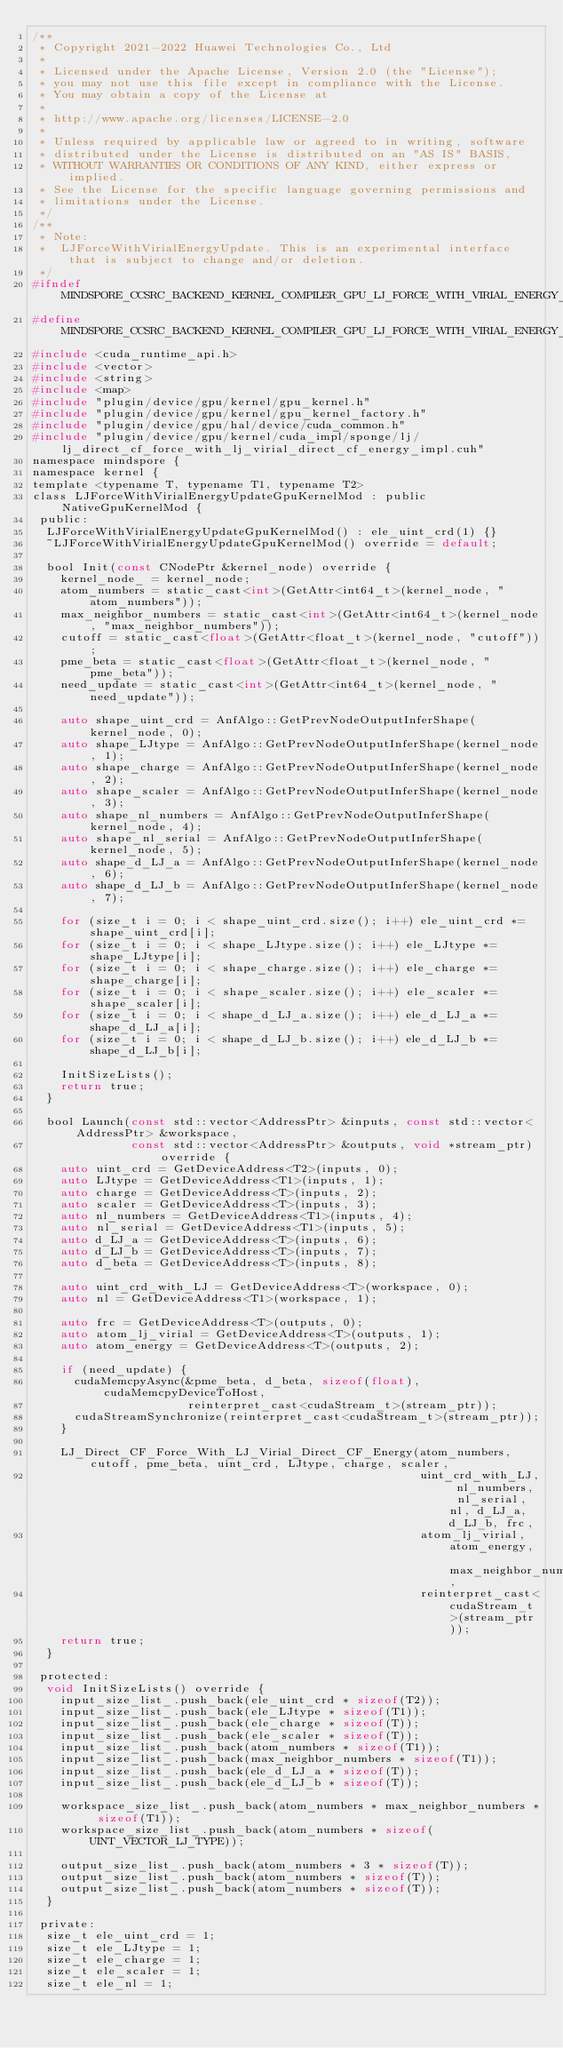Convert code to text. <code><loc_0><loc_0><loc_500><loc_500><_C_>/**
 * Copyright 2021-2022 Huawei Technologies Co., Ltd
 *
 * Licensed under the Apache License, Version 2.0 (the "License");
 * you may not use this file except in compliance with the License.
 * You may obtain a copy of the License at
 *
 * http://www.apache.org/licenses/LICENSE-2.0
 *
 * Unless required by applicable law or agreed to in writing, software
 * distributed under the License is distributed on an "AS IS" BASIS,
 * WITHOUT WARRANTIES OR CONDITIONS OF ANY KIND, either express or implied.
 * See the License for the specific language governing permissions and
 * limitations under the License.
 */
/**
 * Note:
 *  LJForceWithVirialEnergyUpdate. This is an experimental interface that is subject to change and/or deletion.
 */
#ifndef MINDSPORE_CCSRC_BACKEND_KERNEL_COMPILER_GPU_LJ_FORCE_WITH_VIRIAL_ENERGY_UPDATE_KERNEL_H_
#define MINDSPORE_CCSRC_BACKEND_KERNEL_COMPILER_GPU_LJ_FORCE_WITH_VIRIAL_ENERGY_UPDATE_KERNEL_H_
#include <cuda_runtime_api.h>
#include <vector>
#include <string>
#include <map>
#include "plugin/device/gpu/kernel/gpu_kernel.h"
#include "plugin/device/gpu/kernel/gpu_kernel_factory.h"
#include "plugin/device/gpu/hal/device/cuda_common.h"
#include "plugin/device/gpu/kernel/cuda_impl/sponge/lj/lj_direct_cf_force_with_lj_virial_direct_cf_energy_impl.cuh"
namespace mindspore {
namespace kernel {
template <typename T, typename T1, typename T2>
class LJForceWithVirialEnergyUpdateGpuKernelMod : public NativeGpuKernelMod {
 public:
  LJForceWithVirialEnergyUpdateGpuKernelMod() : ele_uint_crd(1) {}
  ~LJForceWithVirialEnergyUpdateGpuKernelMod() override = default;

  bool Init(const CNodePtr &kernel_node) override {
    kernel_node_ = kernel_node;
    atom_numbers = static_cast<int>(GetAttr<int64_t>(kernel_node, "atom_numbers"));
    max_neighbor_numbers = static_cast<int>(GetAttr<int64_t>(kernel_node, "max_neighbor_numbers"));
    cutoff = static_cast<float>(GetAttr<float_t>(kernel_node, "cutoff"));
    pme_beta = static_cast<float>(GetAttr<float_t>(kernel_node, "pme_beta"));
    need_update = static_cast<int>(GetAttr<int64_t>(kernel_node, "need_update"));

    auto shape_uint_crd = AnfAlgo::GetPrevNodeOutputInferShape(kernel_node, 0);
    auto shape_LJtype = AnfAlgo::GetPrevNodeOutputInferShape(kernel_node, 1);
    auto shape_charge = AnfAlgo::GetPrevNodeOutputInferShape(kernel_node, 2);
    auto shape_scaler = AnfAlgo::GetPrevNodeOutputInferShape(kernel_node, 3);
    auto shape_nl_numbers = AnfAlgo::GetPrevNodeOutputInferShape(kernel_node, 4);
    auto shape_nl_serial = AnfAlgo::GetPrevNodeOutputInferShape(kernel_node, 5);
    auto shape_d_LJ_a = AnfAlgo::GetPrevNodeOutputInferShape(kernel_node, 6);
    auto shape_d_LJ_b = AnfAlgo::GetPrevNodeOutputInferShape(kernel_node, 7);

    for (size_t i = 0; i < shape_uint_crd.size(); i++) ele_uint_crd *= shape_uint_crd[i];
    for (size_t i = 0; i < shape_LJtype.size(); i++) ele_LJtype *= shape_LJtype[i];
    for (size_t i = 0; i < shape_charge.size(); i++) ele_charge *= shape_charge[i];
    for (size_t i = 0; i < shape_scaler.size(); i++) ele_scaler *= shape_scaler[i];
    for (size_t i = 0; i < shape_d_LJ_a.size(); i++) ele_d_LJ_a *= shape_d_LJ_a[i];
    for (size_t i = 0; i < shape_d_LJ_b.size(); i++) ele_d_LJ_b *= shape_d_LJ_b[i];

    InitSizeLists();
    return true;
  }

  bool Launch(const std::vector<AddressPtr> &inputs, const std::vector<AddressPtr> &workspace,
              const std::vector<AddressPtr> &outputs, void *stream_ptr) override {
    auto uint_crd = GetDeviceAddress<T2>(inputs, 0);
    auto LJtype = GetDeviceAddress<T1>(inputs, 1);
    auto charge = GetDeviceAddress<T>(inputs, 2);
    auto scaler = GetDeviceAddress<T>(inputs, 3);
    auto nl_numbers = GetDeviceAddress<T1>(inputs, 4);
    auto nl_serial = GetDeviceAddress<T1>(inputs, 5);
    auto d_LJ_a = GetDeviceAddress<T>(inputs, 6);
    auto d_LJ_b = GetDeviceAddress<T>(inputs, 7);
    auto d_beta = GetDeviceAddress<T>(inputs, 8);

    auto uint_crd_with_LJ = GetDeviceAddress<T>(workspace, 0);
    auto nl = GetDeviceAddress<T1>(workspace, 1);

    auto frc = GetDeviceAddress<T>(outputs, 0);
    auto atom_lj_virial = GetDeviceAddress<T>(outputs, 1);
    auto atom_energy = GetDeviceAddress<T>(outputs, 2);

    if (need_update) {
      cudaMemcpyAsync(&pme_beta, d_beta, sizeof(float), cudaMemcpyDeviceToHost,
                      reinterpret_cast<cudaStream_t>(stream_ptr));
      cudaStreamSynchronize(reinterpret_cast<cudaStream_t>(stream_ptr));
    }

    LJ_Direct_CF_Force_With_LJ_Virial_Direct_CF_Energy(atom_numbers, cutoff, pme_beta, uint_crd, LJtype, charge, scaler,
                                                       uint_crd_with_LJ, nl_numbers, nl_serial, nl, d_LJ_a, d_LJ_b, frc,
                                                       atom_lj_virial, atom_energy, max_neighbor_numbers,
                                                       reinterpret_cast<cudaStream_t>(stream_ptr));
    return true;
  }

 protected:
  void InitSizeLists() override {
    input_size_list_.push_back(ele_uint_crd * sizeof(T2));
    input_size_list_.push_back(ele_LJtype * sizeof(T1));
    input_size_list_.push_back(ele_charge * sizeof(T));
    input_size_list_.push_back(ele_scaler * sizeof(T));
    input_size_list_.push_back(atom_numbers * sizeof(T1));
    input_size_list_.push_back(max_neighbor_numbers * sizeof(T1));
    input_size_list_.push_back(ele_d_LJ_a * sizeof(T));
    input_size_list_.push_back(ele_d_LJ_b * sizeof(T));

    workspace_size_list_.push_back(atom_numbers * max_neighbor_numbers * sizeof(T1));
    workspace_size_list_.push_back(atom_numbers * sizeof(UINT_VECTOR_LJ_TYPE));

    output_size_list_.push_back(atom_numbers * 3 * sizeof(T));
    output_size_list_.push_back(atom_numbers * sizeof(T));
    output_size_list_.push_back(atom_numbers * sizeof(T));
  }

 private:
  size_t ele_uint_crd = 1;
  size_t ele_LJtype = 1;
  size_t ele_charge = 1;
  size_t ele_scaler = 1;
  size_t ele_nl = 1;</code> 